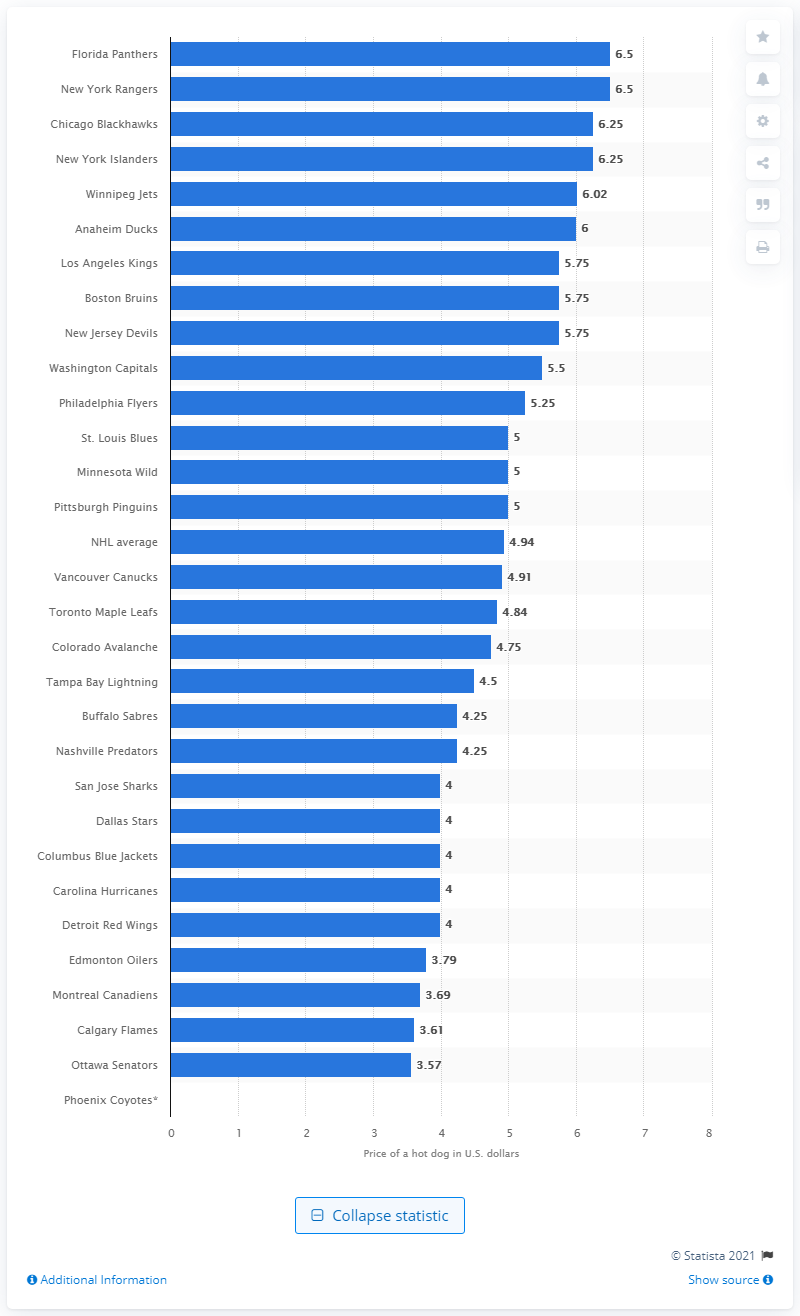Give some essential details in this illustration. The small hot dogs sold at New Jersey Devils games during the 2014/15 season retailed for an average of $5.75 each. 